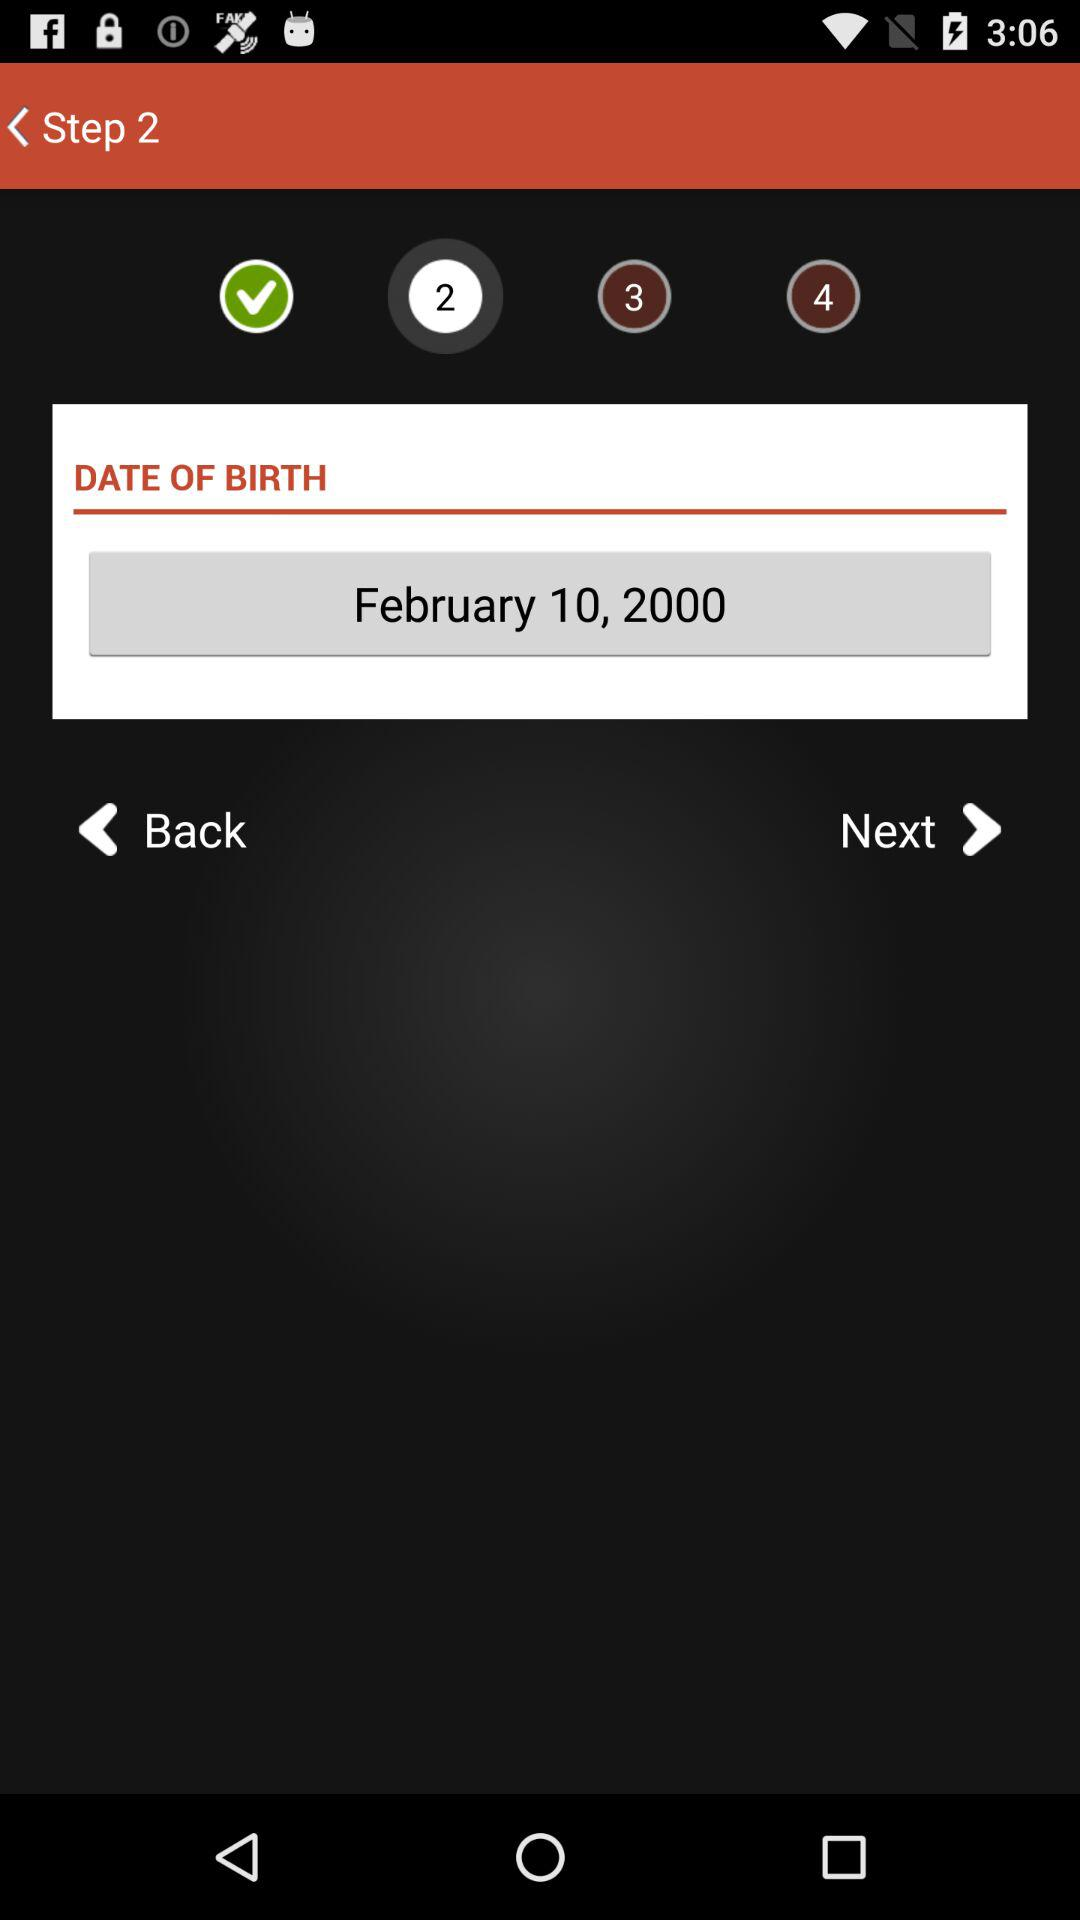What step is currently shown? The shown step is the 2nd. 